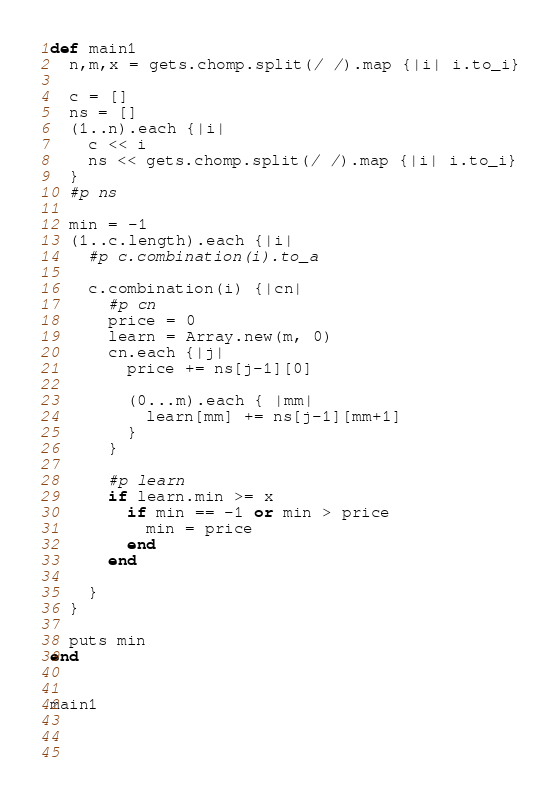Convert code to text. <code><loc_0><loc_0><loc_500><loc_500><_Ruby_>def main1
  n,m,x = gets.chomp.split(/ /).map {|i| i.to_i}

  c = []
  ns = []
  (1..n).each {|i|
    c << i
    ns << gets.chomp.split(/ /).map {|i| i.to_i}
  }
  #p ns

  min = -1
  (1..c.length).each {|i|
    #p c.combination(i).to_a

    c.combination(i) {|cn|
      #p cn
      price = 0
      learn = Array.new(m, 0)
      cn.each {|j|
        price += ns[j-1][0]

        (0...m).each { |mm|
          learn[mm] += ns[j-1][mm+1]
        }
      }

      #p learn
      if learn.min >= x
        if min == -1 or min > price
          min = price
        end
      end

    }
  }

  puts min
end


main1


    
</code> 